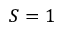<formula> <loc_0><loc_0><loc_500><loc_500>S = 1</formula> 